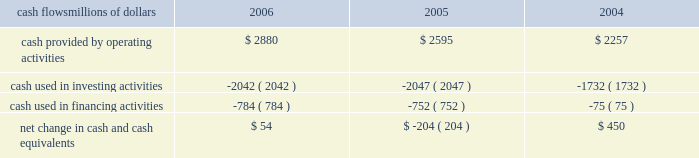Liquidity and capital resources as of december 31 , 2006 , our principal sources of liquidity included cash , cash equivalents , the sale of receivables , and our revolving credit facilities , as well as the availability of commercial paper and other sources of financing through the capital markets .
We had $ 2 billion of committed credit facilities available , of which there were no borrowings outstanding as of december 31 , 2006 , and we did not make any short-term borrowings under these facilities during the year .
The value of the outstanding undivided interest held by investors under the sale of receivables program was $ 600 million as of december 31 , 2006 .
The sale of receivables program is subject to certain requirements , including the maintenance of an investment grade bond rating .
If our bond rating were to deteriorate , it could have an adverse impact on our liquidity .
Access to commercial paper is dependent on market conditions .
Deterioration of our operating results or financial condition due to internal or external factors could negatively impact our ability to utilize commercial paper as a source of liquidity .
Liquidity through the capital markets is also dependent on our financial stability .
At both december 31 , 2006 and 2005 , we had a working capital deficit of approximately $ 1.1 billion .
A working capital deficit is common in our industry and does not indicate a lack of liquidity .
We maintain adequate resources to meet our daily cash requirements , and we have sufficient financial capacity to satisfy our current liabilities .
Financial condition cash flows millions of dollars 2006 2005 2004 .
Cash provided by operating activities 2013 higher income in 2006 generated the increased cash provided by operating activities , which was partially offset by higher income tax payments , $ 150 million in voluntary pension contributions , higher material and supply inventories , and higher management incentive payments in 2006 .
Higher income , lower management incentive payments in 2005 ( executive bonuses , which would have been paid to individuals in 2005 , were not awarded based on company performance in 2004 and bonuses for the professional workforce that were paid out in 2005 were significantly reduced ) , and working capital performance generated higher cash from operating activities in 2005 .
A voluntary pension contribution of $ 100 million in 2004 also augmented the positive year-over-year variance in 2005 as no pension contribution was made in 2005 .
This improvement was partially offset by cash received in 2004 for income tax refunds .
Cash used in investing activities 2013 an insurance settlement for the 2005 january west coast storm and lower balances for work in process decreased the amount of cash used in investing activities in 2006 .
Higher capital investments and lower proceeds from asset sales partially offset this decrease .
Increased capital spending , partially offset by higher proceeds from asset sales , increased the amount of cash used in investing activities in 2005 compared to 2004 .
Cash used in financing activities 2013 the increase in cash used in financing activities primarily resulted from lower net proceeds from equity compensation plans ( $ 189 million in 2006 compared to $ 262 million in 2005 ) .
The increase in 2005 results from debt issuances in 2004 and higher debt repayments in 2005 .
We did not issue debt in 2005 versus $ 745 million of debt issuances in 2004 , and we repaid $ 699 million of debt in 2005 compared to $ 588 million in 2004 .
The higher outflows in 2005 were partially offset by higher net proceeds from equity compensation plans ( $ 262 million in 2005 compared to $ 80 million in 2004 ) . .
What was the percentage change in cash provided by operating activities between 2004 and 2005? 
Computations: ((2595 - 2257) / 2257)
Answer: 0.14976. 